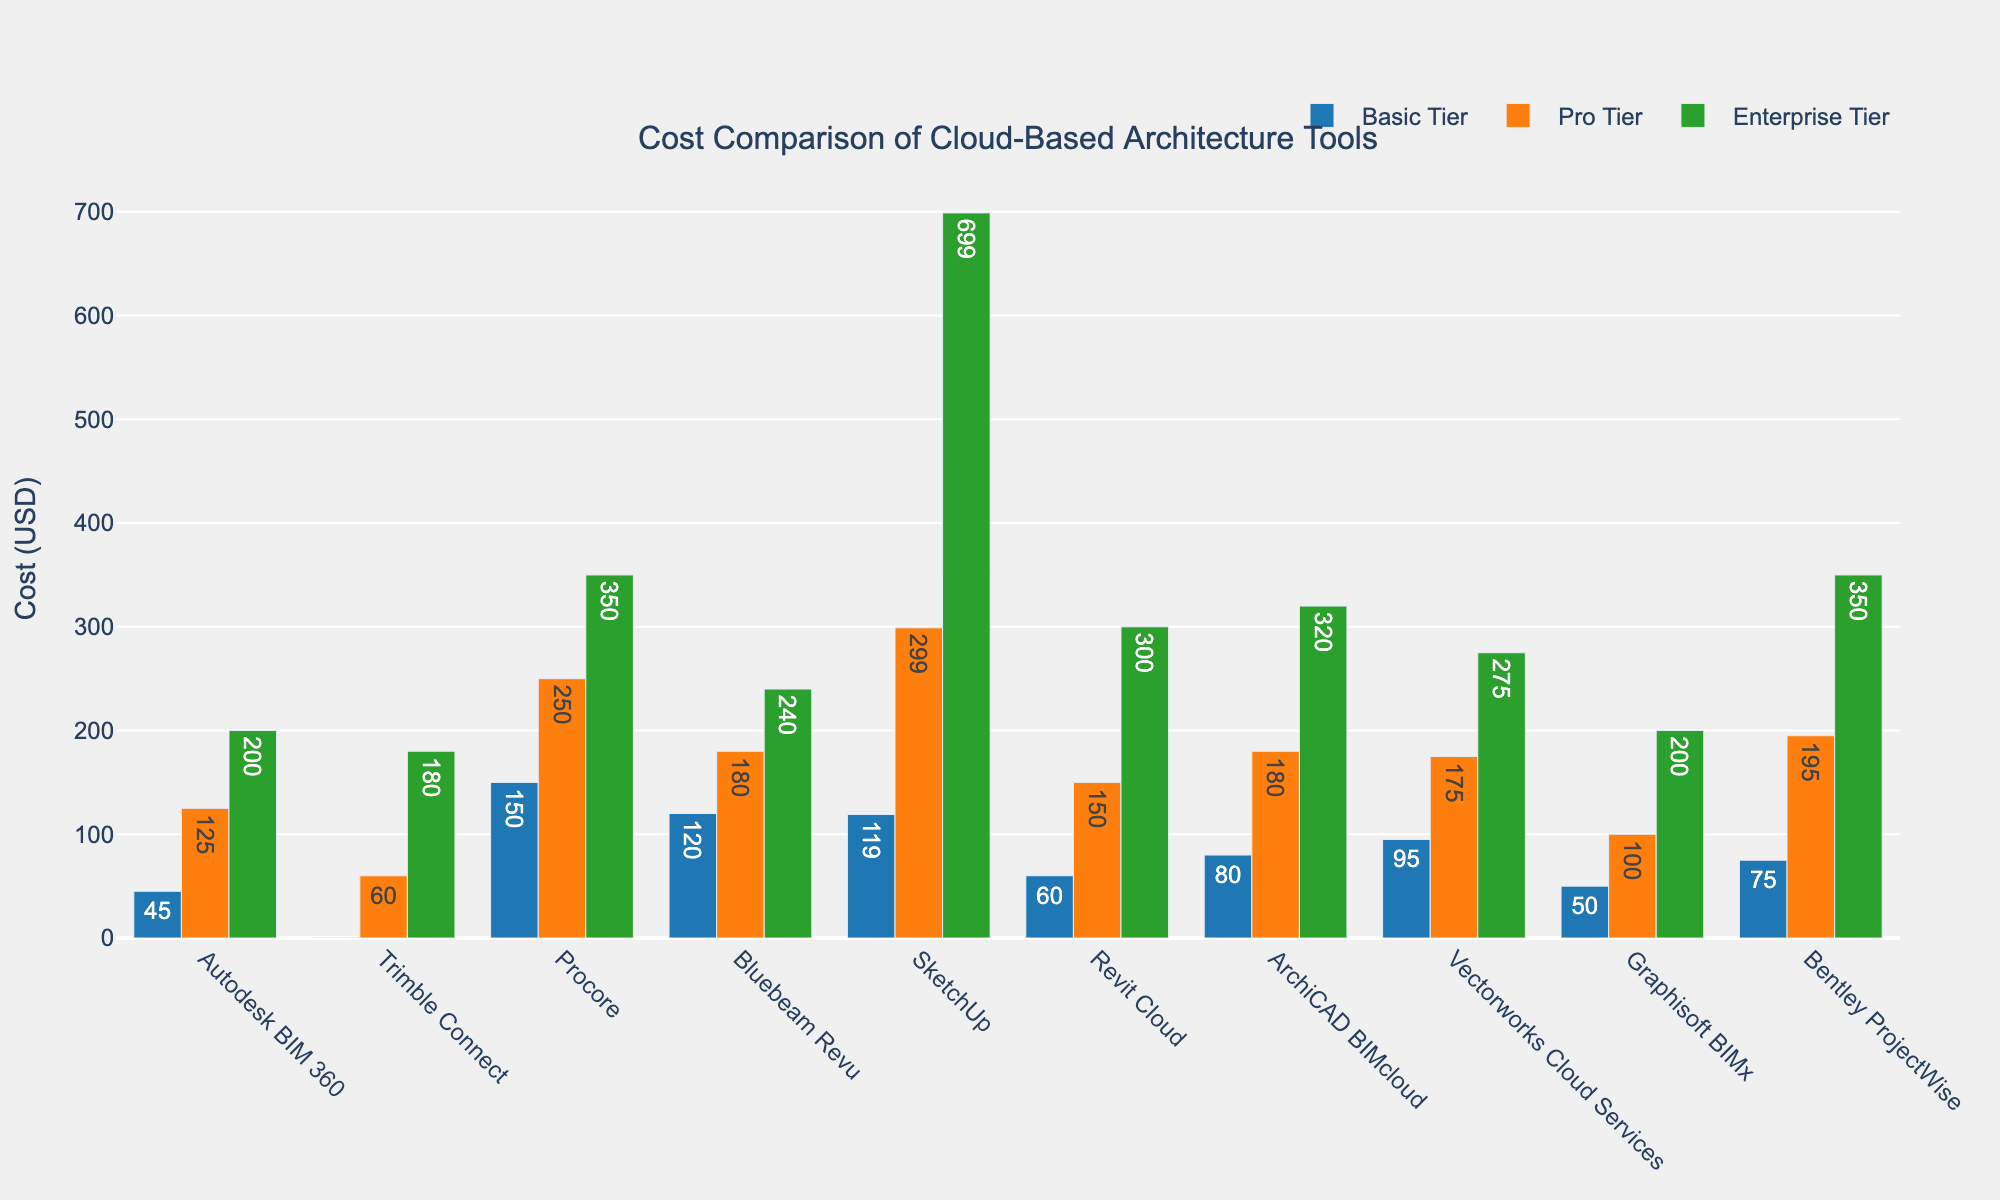What's the cost difference between the Basic and Enterprise tiers for Procore? The cost for the Basic tier is 150 USD and for the Enterprise tier is 350 USD. The difference is calculated by subtracting the Basic tier cost from the Enterprise tier cost: 350 - 150 = 200 USD.
Answer: 200 USD Which tool has the highest cost in the Pro Tier? By visually inspecting the heights of the bars in the Pro Tier (colored orange), Procore stands out as the highest with a cost of 250 USD.
Answer: Procore What is the average cost of the Basic Tier across all tools? Sum the costs of the Basic Tier across all tools (45 + 0 + 150 + 120 + 119 + 60 + 80 + 95 + 50 + 75) which equals 794 USD. Then, divide by the number of tools (10): 794 / 10 = 79.4 USD.
Answer: 79.4 USD Which tool offers a free Basic tier? By checking the Basic tier bars, Trimble Connect shows a cost of 0 USD in the Basic tier, meaning it is free.
Answer: Trimble Connect What's the combined cost of the Enterprise tier for Bluebeam Revu and Bentley ProjectWise? Add the costs for both tools in the Enterprise tier: 240 (Bluebeam Revu) + 350 (Bentley ProjectWise) = 590 USD.
Answer: 590 USD In the Basic Tier, which tool costs more: SketchUp or Vectorworks Cloud Services? Compare the heights of the blue bars for both tools, SketchUp (119 USD) and Vectorworks Cloud Services (95 USD). SketchUp is more expensive.
Answer: SketchUp 